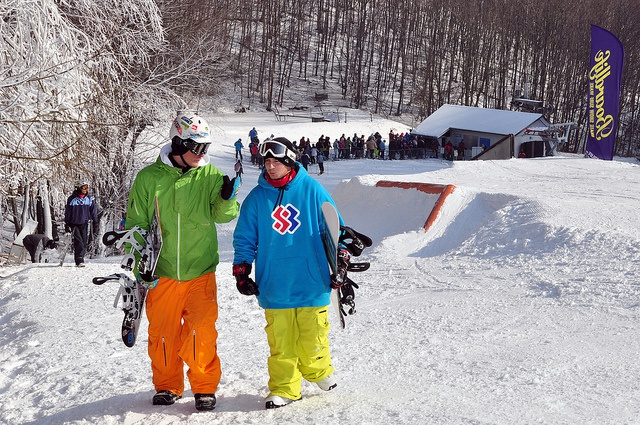Describe the objects in this image and their specific colors. I can see people in gray, red, green, and black tones, people in gray, blue, olive, black, and lightblue tones, snowboard in gray, black, darkgray, and lightgray tones, people in gray, black, navy, and darkgray tones, and people in gray, black, white, and navy tones in this image. 